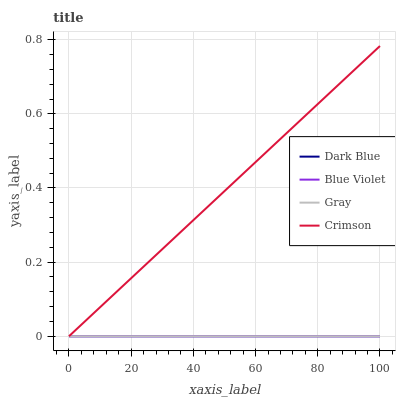Does Dark Blue have the minimum area under the curve?
Answer yes or no. Yes. Does Crimson have the maximum area under the curve?
Answer yes or no. Yes. Does Gray have the maximum area under the curve?
Answer yes or no. No. Is Dark Blue the smoothest?
Answer yes or no. Yes. Is Crimson the roughest?
Answer yes or no. Yes. Is Gray the roughest?
Answer yes or no. No. Does Crimson have the lowest value?
Answer yes or no. Yes. Does Crimson have the highest value?
Answer yes or no. Yes. Does Gray have the highest value?
Answer yes or no. No. Does Blue Violet intersect Dark Blue?
Answer yes or no. Yes. Is Blue Violet less than Dark Blue?
Answer yes or no. No. Is Blue Violet greater than Dark Blue?
Answer yes or no. No. 